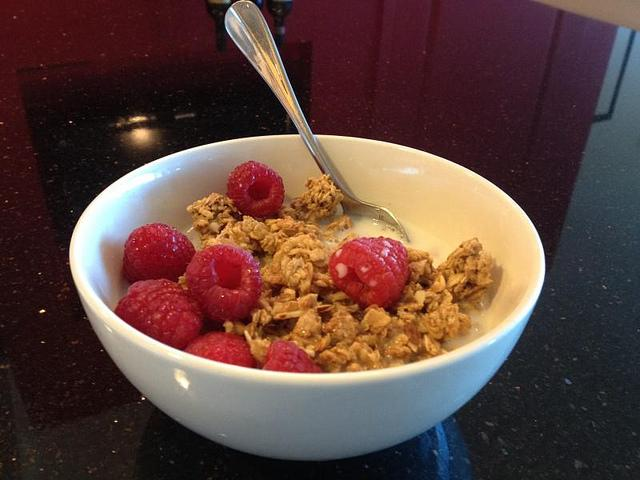Based on the reflections where is this bowl of cereal placed? counter 